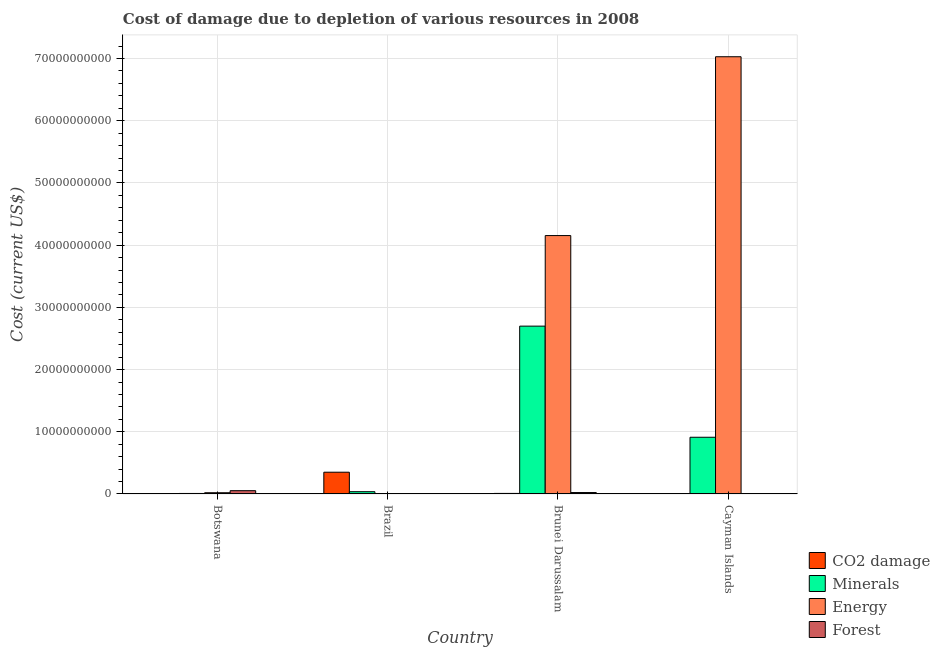How many different coloured bars are there?
Offer a terse response. 4. How many groups of bars are there?
Your answer should be very brief. 4. Are the number of bars on each tick of the X-axis equal?
Make the answer very short. Yes. What is the label of the 4th group of bars from the left?
Offer a very short reply. Cayman Islands. In how many cases, is the number of bars for a given country not equal to the number of legend labels?
Offer a very short reply. 0. What is the cost of damage due to depletion of energy in Brunei Darussalam?
Provide a short and direct response. 4.15e+1. Across all countries, what is the maximum cost of damage due to depletion of minerals?
Offer a very short reply. 2.70e+1. Across all countries, what is the minimum cost of damage due to depletion of energy?
Ensure brevity in your answer.  3.07e+07. In which country was the cost of damage due to depletion of forests maximum?
Offer a very short reply. Botswana. In which country was the cost of damage due to depletion of energy minimum?
Offer a terse response. Brazil. What is the total cost of damage due to depletion of minerals in the graph?
Provide a succinct answer. 3.65e+1. What is the difference between the cost of damage due to depletion of coal in Brazil and that in Brunei Darussalam?
Offer a very short reply. 3.41e+09. What is the difference between the cost of damage due to depletion of coal in Cayman Islands and the cost of damage due to depletion of energy in Brazil?
Keep it short and to the point. -2.53e+07. What is the average cost of damage due to depletion of energy per country?
Offer a terse response. 2.80e+1. What is the difference between the cost of damage due to depletion of coal and cost of damage due to depletion of forests in Botswana?
Keep it short and to the point. -4.84e+08. What is the ratio of the cost of damage due to depletion of energy in Brunei Darussalam to that in Cayman Islands?
Offer a terse response. 0.59. Is the cost of damage due to depletion of forests in Botswana less than that in Brazil?
Offer a very short reply. No. What is the difference between the highest and the second highest cost of damage due to depletion of coal?
Offer a terse response. 3.41e+09. What is the difference between the highest and the lowest cost of damage due to depletion of coal?
Keep it short and to the point. 3.49e+09. In how many countries, is the cost of damage due to depletion of energy greater than the average cost of damage due to depletion of energy taken over all countries?
Offer a terse response. 2. What does the 4th bar from the left in Brunei Darussalam represents?
Offer a terse response. Forest. What does the 4th bar from the right in Cayman Islands represents?
Offer a very short reply. CO2 damage. Is it the case that in every country, the sum of the cost of damage due to depletion of coal and cost of damage due to depletion of minerals is greater than the cost of damage due to depletion of energy?
Provide a short and direct response. No. Are all the bars in the graph horizontal?
Your answer should be compact. No. What is the difference between two consecutive major ticks on the Y-axis?
Offer a terse response. 1.00e+1. Are the values on the major ticks of Y-axis written in scientific E-notation?
Provide a succinct answer. No. Does the graph contain any zero values?
Provide a short and direct response. No. Does the graph contain grids?
Offer a very short reply. Yes. Where does the legend appear in the graph?
Provide a short and direct response. Bottom right. How many legend labels are there?
Offer a terse response. 4. What is the title of the graph?
Offer a terse response. Cost of damage due to depletion of various resources in 2008 . What is the label or title of the Y-axis?
Your answer should be compact. Cost (current US$). What is the Cost (current US$) in CO2 damage in Botswana?
Make the answer very short. 4.49e+07. What is the Cost (current US$) of Minerals in Botswana?
Ensure brevity in your answer.  8.10e+07. What is the Cost (current US$) in Energy in Botswana?
Your answer should be very brief. 1.99e+08. What is the Cost (current US$) of Forest in Botswana?
Offer a terse response. 5.28e+08. What is the Cost (current US$) of CO2 damage in Brazil?
Ensure brevity in your answer.  3.50e+09. What is the Cost (current US$) of Minerals in Brazil?
Your answer should be compact. 3.66e+08. What is the Cost (current US$) in Energy in Brazil?
Offer a terse response. 3.07e+07. What is the Cost (current US$) of Forest in Brazil?
Give a very brief answer. 5.44e+06. What is the Cost (current US$) of CO2 damage in Brunei Darussalam?
Offer a terse response. 9.05e+07. What is the Cost (current US$) in Minerals in Brunei Darussalam?
Provide a short and direct response. 2.70e+1. What is the Cost (current US$) of Energy in Brunei Darussalam?
Offer a very short reply. 4.15e+1. What is the Cost (current US$) of Forest in Brunei Darussalam?
Your answer should be compact. 2.31e+08. What is the Cost (current US$) in CO2 damage in Cayman Islands?
Keep it short and to the point. 5.36e+06. What is the Cost (current US$) of Minerals in Cayman Islands?
Offer a very short reply. 9.12e+09. What is the Cost (current US$) of Energy in Cayman Islands?
Provide a succinct answer. 7.03e+1. What is the Cost (current US$) in Forest in Cayman Islands?
Offer a very short reply. 1.58e+07. Across all countries, what is the maximum Cost (current US$) of CO2 damage?
Ensure brevity in your answer.  3.50e+09. Across all countries, what is the maximum Cost (current US$) in Minerals?
Give a very brief answer. 2.70e+1. Across all countries, what is the maximum Cost (current US$) of Energy?
Offer a terse response. 7.03e+1. Across all countries, what is the maximum Cost (current US$) of Forest?
Your answer should be very brief. 5.28e+08. Across all countries, what is the minimum Cost (current US$) in CO2 damage?
Give a very brief answer. 5.36e+06. Across all countries, what is the minimum Cost (current US$) in Minerals?
Offer a terse response. 8.10e+07. Across all countries, what is the minimum Cost (current US$) in Energy?
Your response must be concise. 3.07e+07. Across all countries, what is the minimum Cost (current US$) in Forest?
Your response must be concise. 5.44e+06. What is the total Cost (current US$) in CO2 damage in the graph?
Your answer should be compact. 3.64e+09. What is the total Cost (current US$) in Minerals in the graph?
Provide a short and direct response. 3.65e+1. What is the total Cost (current US$) in Energy in the graph?
Offer a very short reply. 1.12e+11. What is the total Cost (current US$) of Forest in the graph?
Keep it short and to the point. 7.81e+08. What is the difference between the Cost (current US$) of CO2 damage in Botswana and that in Brazil?
Ensure brevity in your answer.  -3.45e+09. What is the difference between the Cost (current US$) of Minerals in Botswana and that in Brazil?
Provide a succinct answer. -2.85e+08. What is the difference between the Cost (current US$) of Energy in Botswana and that in Brazil?
Provide a succinct answer. 1.68e+08. What is the difference between the Cost (current US$) of Forest in Botswana and that in Brazil?
Make the answer very short. 5.23e+08. What is the difference between the Cost (current US$) of CO2 damage in Botswana and that in Brunei Darussalam?
Your answer should be compact. -4.56e+07. What is the difference between the Cost (current US$) in Minerals in Botswana and that in Brunei Darussalam?
Provide a short and direct response. -2.69e+1. What is the difference between the Cost (current US$) of Energy in Botswana and that in Brunei Darussalam?
Provide a short and direct response. -4.13e+1. What is the difference between the Cost (current US$) in Forest in Botswana and that in Brunei Darussalam?
Your answer should be compact. 2.97e+08. What is the difference between the Cost (current US$) of CO2 damage in Botswana and that in Cayman Islands?
Your answer should be very brief. 3.96e+07. What is the difference between the Cost (current US$) in Minerals in Botswana and that in Cayman Islands?
Offer a very short reply. -9.04e+09. What is the difference between the Cost (current US$) in Energy in Botswana and that in Cayman Islands?
Your response must be concise. -7.01e+1. What is the difference between the Cost (current US$) in Forest in Botswana and that in Cayman Islands?
Your response must be concise. 5.13e+08. What is the difference between the Cost (current US$) of CO2 damage in Brazil and that in Brunei Darussalam?
Provide a succinct answer. 3.41e+09. What is the difference between the Cost (current US$) of Minerals in Brazil and that in Brunei Darussalam?
Your answer should be compact. -2.66e+1. What is the difference between the Cost (current US$) of Energy in Brazil and that in Brunei Darussalam?
Give a very brief answer. -4.15e+1. What is the difference between the Cost (current US$) in Forest in Brazil and that in Brunei Darussalam?
Provide a succinct answer. -2.26e+08. What is the difference between the Cost (current US$) in CO2 damage in Brazil and that in Cayman Islands?
Your response must be concise. 3.49e+09. What is the difference between the Cost (current US$) in Minerals in Brazil and that in Cayman Islands?
Give a very brief answer. -8.75e+09. What is the difference between the Cost (current US$) of Energy in Brazil and that in Cayman Islands?
Your response must be concise. -7.03e+1. What is the difference between the Cost (current US$) of Forest in Brazil and that in Cayman Islands?
Provide a short and direct response. -1.04e+07. What is the difference between the Cost (current US$) of CO2 damage in Brunei Darussalam and that in Cayman Islands?
Make the answer very short. 8.51e+07. What is the difference between the Cost (current US$) in Minerals in Brunei Darussalam and that in Cayman Islands?
Give a very brief answer. 1.79e+1. What is the difference between the Cost (current US$) in Energy in Brunei Darussalam and that in Cayman Islands?
Give a very brief answer. -2.88e+1. What is the difference between the Cost (current US$) in Forest in Brunei Darussalam and that in Cayman Islands?
Provide a short and direct response. 2.15e+08. What is the difference between the Cost (current US$) of CO2 damage in Botswana and the Cost (current US$) of Minerals in Brazil?
Your answer should be very brief. -3.21e+08. What is the difference between the Cost (current US$) of CO2 damage in Botswana and the Cost (current US$) of Energy in Brazil?
Ensure brevity in your answer.  1.42e+07. What is the difference between the Cost (current US$) in CO2 damage in Botswana and the Cost (current US$) in Forest in Brazil?
Make the answer very short. 3.95e+07. What is the difference between the Cost (current US$) of Minerals in Botswana and the Cost (current US$) of Energy in Brazil?
Keep it short and to the point. 5.03e+07. What is the difference between the Cost (current US$) in Minerals in Botswana and the Cost (current US$) in Forest in Brazil?
Give a very brief answer. 7.56e+07. What is the difference between the Cost (current US$) of Energy in Botswana and the Cost (current US$) of Forest in Brazil?
Give a very brief answer. 1.93e+08. What is the difference between the Cost (current US$) of CO2 damage in Botswana and the Cost (current US$) of Minerals in Brunei Darussalam?
Give a very brief answer. -2.69e+1. What is the difference between the Cost (current US$) of CO2 damage in Botswana and the Cost (current US$) of Energy in Brunei Darussalam?
Offer a terse response. -4.15e+1. What is the difference between the Cost (current US$) in CO2 damage in Botswana and the Cost (current US$) in Forest in Brunei Darussalam?
Keep it short and to the point. -1.86e+08. What is the difference between the Cost (current US$) in Minerals in Botswana and the Cost (current US$) in Energy in Brunei Darussalam?
Your answer should be very brief. -4.15e+1. What is the difference between the Cost (current US$) of Minerals in Botswana and the Cost (current US$) of Forest in Brunei Darussalam?
Your answer should be very brief. -1.50e+08. What is the difference between the Cost (current US$) of Energy in Botswana and the Cost (current US$) of Forest in Brunei Darussalam?
Your answer should be very brief. -3.23e+07. What is the difference between the Cost (current US$) of CO2 damage in Botswana and the Cost (current US$) of Minerals in Cayman Islands?
Give a very brief answer. -9.07e+09. What is the difference between the Cost (current US$) in CO2 damage in Botswana and the Cost (current US$) in Energy in Cayman Islands?
Your answer should be very brief. -7.02e+1. What is the difference between the Cost (current US$) of CO2 damage in Botswana and the Cost (current US$) of Forest in Cayman Islands?
Your response must be concise. 2.91e+07. What is the difference between the Cost (current US$) of Minerals in Botswana and the Cost (current US$) of Energy in Cayman Islands?
Your answer should be compact. -7.02e+1. What is the difference between the Cost (current US$) of Minerals in Botswana and the Cost (current US$) of Forest in Cayman Islands?
Ensure brevity in your answer.  6.52e+07. What is the difference between the Cost (current US$) in Energy in Botswana and the Cost (current US$) in Forest in Cayman Islands?
Give a very brief answer. 1.83e+08. What is the difference between the Cost (current US$) of CO2 damage in Brazil and the Cost (current US$) of Minerals in Brunei Darussalam?
Give a very brief answer. -2.35e+1. What is the difference between the Cost (current US$) of CO2 damage in Brazil and the Cost (current US$) of Energy in Brunei Darussalam?
Offer a very short reply. -3.80e+1. What is the difference between the Cost (current US$) of CO2 damage in Brazil and the Cost (current US$) of Forest in Brunei Darussalam?
Ensure brevity in your answer.  3.27e+09. What is the difference between the Cost (current US$) of Minerals in Brazil and the Cost (current US$) of Energy in Brunei Darussalam?
Provide a short and direct response. -4.12e+1. What is the difference between the Cost (current US$) of Minerals in Brazil and the Cost (current US$) of Forest in Brunei Darussalam?
Keep it short and to the point. 1.35e+08. What is the difference between the Cost (current US$) of Energy in Brazil and the Cost (current US$) of Forest in Brunei Darussalam?
Give a very brief answer. -2.00e+08. What is the difference between the Cost (current US$) in CO2 damage in Brazil and the Cost (current US$) in Minerals in Cayman Islands?
Provide a short and direct response. -5.62e+09. What is the difference between the Cost (current US$) of CO2 damage in Brazil and the Cost (current US$) of Energy in Cayman Islands?
Ensure brevity in your answer.  -6.68e+1. What is the difference between the Cost (current US$) in CO2 damage in Brazil and the Cost (current US$) in Forest in Cayman Islands?
Give a very brief answer. 3.48e+09. What is the difference between the Cost (current US$) of Minerals in Brazil and the Cost (current US$) of Energy in Cayman Islands?
Your answer should be very brief. -6.99e+1. What is the difference between the Cost (current US$) in Minerals in Brazil and the Cost (current US$) in Forest in Cayman Islands?
Make the answer very short. 3.50e+08. What is the difference between the Cost (current US$) in Energy in Brazil and the Cost (current US$) in Forest in Cayman Islands?
Your answer should be very brief. 1.49e+07. What is the difference between the Cost (current US$) in CO2 damage in Brunei Darussalam and the Cost (current US$) in Minerals in Cayman Islands?
Keep it short and to the point. -9.03e+09. What is the difference between the Cost (current US$) of CO2 damage in Brunei Darussalam and the Cost (current US$) of Energy in Cayman Islands?
Provide a short and direct response. -7.02e+1. What is the difference between the Cost (current US$) of CO2 damage in Brunei Darussalam and the Cost (current US$) of Forest in Cayman Islands?
Provide a short and direct response. 7.47e+07. What is the difference between the Cost (current US$) of Minerals in Brunei Darussalam and the Cost (current US$) of Energy in Cayman Islands?
Offer a very short reply. -4.33e+1. What is the difference between the Cost (current US$) in Minerals in Brunei Darussalam and the Cost (current US$) in Forest in Cayman Islands?
Offer a terse response. 2.70e+1. What is the difference between the Cost (current US$) of Energy in Brunei Darussalam and the Cost (current US$) of Forest in Cayman Islands?
Your answer should be very brief. 4.15e+1. What is the average Cost (current US$) of CO2 damage per country?
Your answer should be compact. 9.10e+08. What is the average Cost (current US$) in Minerals per country?
Provide a short and direct response. 9.14e+09. What is the average Cost (current US$) in Energy per country?
Keep it short and to the point. 2.80e+1. What is the average Cost (current US$) in Forest per country?
Make the answer very short. 1.95e+08. What is the difference between the Cost (current US$) of CO2 damage and Cost (current US$) of Minerals in Botswana?
Your response must be concise. -3.61e+07. What is the difference between the Cost (current US$) in CO2 damage and Cost (current US$) in Energy in Botswana?
Your answer should be compact. -1.54e+08. What is the difference between the Cost (current US$) in CO2 damage and Cost (current US$) in Forest in Botswana?
Provide a short and direct response. -4.84e+08. What is the difference between the Cost (current US$) of Minerals and Cost (current US$) of Energy in Botswana?
Your answer should be very brief. -1.18e+08. What is the difference between the Cost (current US$) in Minerals and Cost (current US$) in Forest in Botswana?
Give a very brief answer. -4.47e+08. What is the difference between the Cost (current US$) in Energy and Cost (current US$) in Forest in Botswana?
Make the answer very short. -3.30e+08. What is the difference between the Cost (current US$) of CO2 damage and Cost (current US$) of Minerals in Brazil?
Your answer should be very brief. 3.13e+09. What is the difference between the Cost (current US$) in CO2 damage and Cost (current US$) in Energy in Brazil?
Your answer should be very brief. 3.47e+09. What is the difference between the Cost (current US$) of CO2 damage and Cost (current US$) of Forest in Brazil?
Your response must be concise. 3.49e+09. What is the difference between the Cost (current US$) in Minerals and Cost (current US$) in Energy in Brazil?
Provide a succinct answer. 3.35e+08. What is the difference between the Cost (current US$) in Minerals and Cost (current US$) in Forest in Brazil?
Offer a terse response. 3.60e+08. What is the difference between the Cost (current US$) of Energy and Cost (current US$) of Forest in Brazil?
Provide a short and direct response. 2.53e+07. What is the difference between the Cost (current US$) of CO2 damage and Cost (current US$) of Minerals in Brunei Darussalam?
Provide a short and direct response. -2.69e+1. What is the difference between the Cost (current US$) in CO2 damage and Cost (current US$) in Energy in Brunei Darussalam?
Your answer should be compact. -4.15e+1. What is the difference between the Cost (current US$) of CO2 damage and Cost (current US$) of Forest in Brunei Darussalam?
Your answer should be very brief. -1.40e+08. What is the difference between the Cost (current US$) in Minerals and Cost (current US$) in Energy in Brunei Darussalam?
Provide a succinct answer. -1.46e+1. What is the difference between the Cost (current US$) of Minerals and Cost (current US$) of Forest in Brunei Darussalam?
Offer a very short reply. 2.68e+1. What is the difference between the Cost (current US$) of Energy and Cost (current US$) of Forest in Brunei Darussalam?
Make the answer very short. 4.13e+1. What is the difference between the Cost (current US$) of CO2 damage and Cost (current US$) of Minerals in Cayman Islands?
Keep it short and to the point. -9.11e+09. What is the difference between the Cost (current US$) of CO2 damage and Cost (current US$) of Energy in Cayman Islands?
Provide a succinct answer. -7.03e+1. What is the difference between the Cost (current US$) in CO2 damage and Cost (current US$) in Forest in Cayman Islands?
Offer a very short reply. -1.05e+07. What is the difference between the Cost (current US$) in Minerals and Cost (current US$) in Energy in Cayman Islands?
Provide a short and direct response. -6.12e+1. What is the difference between the Cost (current US$) in Minerals and Cost (current US$) in Forest in Cayman Islands?
Give a very brief answer. 9.10e+09. What is the difference between the Cost (current US$) of Energy and Cost (current US$) of Forest in Cayman Islands?
Provide a succinct answer. 7.03e+1. What is the ratio of the Cost (current US$) in CO2 damage in Botswana to that in Brazil?
Provide a short and direct response. 0.01. What is the ratio of the Cost (current US$) in Minerals in Botswana to that in Brazil?
Offer a terse response. 0.22. What is the ratio of the Cost (current US$) of Energy in Botswana to that in Brazil?
Provide a short and direct response. 6.47. What is the ratio of the Cost (current US$) of Forest in Botswana to that in Brazil?
Your answer should be compact. 97.21. What is the ratio of the Cost (current US$) in CO2 damage in Botswana to that in Brunei Darussalam?
Your response must be concise. 0.5. What is the ratio of the Cost (current US$) in Minerals in Botswana to that in Brunei Darussalam?
Keep it short and to the point. 0. What is the ratio of the Cost (current US$) in Energy in Botswana to that in Brunei Darussalam?
Give a very brief answer. 0. What is the ratio of the Cost (current US$) of Forest in Botswana to that in Brunei Darussalam?
Offer a terse response. 2.29. What is the ratio of the Cost (current US$) of CO2 damage in Botswana to that in Cayman Islands?
Your answer should be compact. 8.38. What is the ratio of the Cost (current US$) of Minerals in Botswana to that in Cayman Islands?
Provide a short and direct response. 0.01. What is the ratio of the Cost (current US$) of Energy in Botswana to that in Cayman Islands?
Keep it short and to the point. 0. What is the ratio of the Cost (current US$) in Forest in Botswana to that in Cayman Islands?
Offer a terse response. 33.37. What is the ratio of the Cost (current US$) in CO2 damage in Brazil to that in Brunei Darussalam?
Provide a short and direct response. 38.65. What is the ratio of the Cost (current US$) in Minerals in Brazil to that in Brunei Darussalam?
Ensure brevity in your answer.  0.01. What is the ratio of the Cost (current US$) in Energy in Brazil to that in Brunei Darussalam?
Keep it short and to the point. 0. What is the ratio of the Cost (current US$) of Forest in Brazil to that in Brunei Darussalam?
Offer a terse response. 0.02. What is the ratio of the Cost (current US$) of CO2 damage in Brazil to that in Cayman Islands?
Provide a succinct answer. 652.59. What is the ratio of the Cost (current US$) in Minerals in Brazil to that in Cayman Islands?
Provide a succinct answer. 0.04. What is the ratio of the Cost (current US$) in Energy in Brazil to that in Cayman Islands?
Offer a terse response. 0. What is the ratio of the Cost (current US$) of Forest in Brazil to that in Cayman Islands?
Make the answer very short. 0.34. What is the ratio of the Cost (current US$) of CO2 damage in Brunei Darussalam to that in Cayman Islands?
Your answer should be compact. 16.88. What is the ratio of the Cost (current US$) in Minerals in Brunei Darussalam to that in Cayman Islands?
Your response must be concise. 2.96. What is the ratio of the Cost (current US$) of Energy in Brunei Darussalam to that in Cayman Islands?
Ensure brevity in your answer.  0.59. What is the ratio of the Cost (current US$) in Forest in Brunei Darussalam to that in Cayman Islands?
Provide a succinct answer. 14.59. What is the difference between the highest and the second highest Cost (current US$) in CO2 damage?
Make the answer very short. 3.41e+09. What is the difference between the highest and the second highest Cost (current US$) in Minerals?
Offer a very short reply. 1.79e+1. What is the difference between the highest and the second highest Cost (current US$) of Energy?
Offer a terse response. 2.88e+1. What is the difference between the highest and the second highest Cost (current US$) in Forest?
Your response must be concise. 2.97e+08. What is the difference between the highest and the lowest Cost (current US$) of CO2 damage?
Provide a short and direct response. 3.49e+09. What is the difference between the highest and the lowest Cost (current US$) in Minerals?
Make the answer very short. 2.69e+1. What is the difference between the highest and the lowest Cost (current US$) in Energy?
Give a very brief answer. 7.03e+1. What is the difference between the highest and the lowest Cost (current US$) in Forest?
Give a very brief answer. 5.23e+08. 